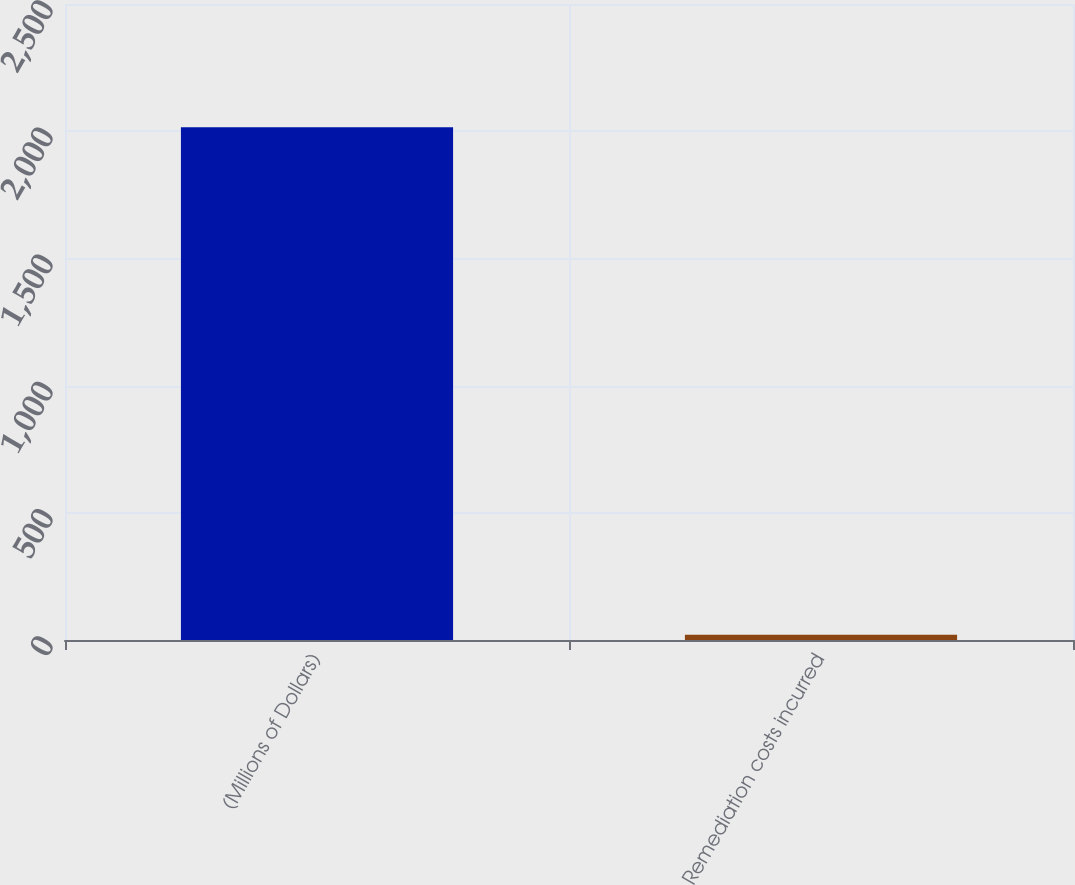Convert chart to OTSL. <chart><loc_0><loc_0><loc_500><loc_500><bar_chart><fcel>(Millions of Dollars)<fcel>Remediation costs incurred<nl><fcel>2016<fcel>21<nl></chart> 